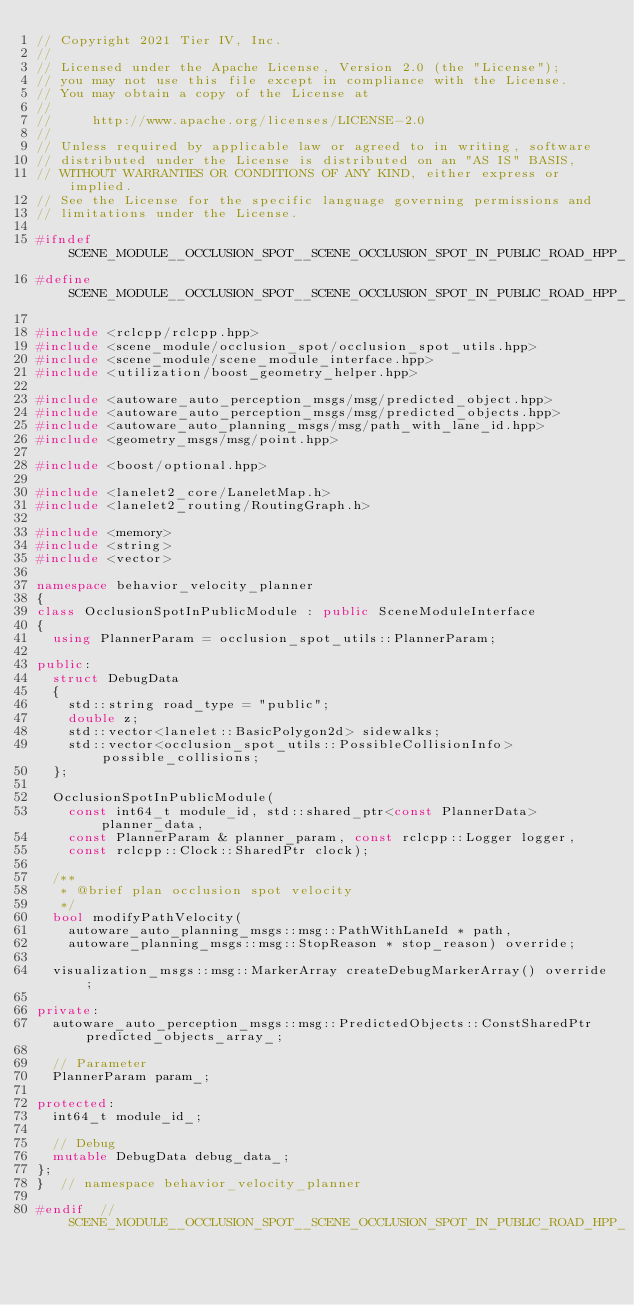Convert code to text. <code><loc_0><loc_0><loc_500><loc_500><_C++_>// Copyright 2021 Tier IV, Inc.
//
// Licensed under the Apache License, Version 2.0 (the "License");
// you may not use this file except in compliance with the License.
// You may obtain a copy of the License at
//
//     http://www.apache.org/licenses/LICENSE-2.0
//
// Unless required by applicable law or agreed to in writing, software
// distributed under the License is distributed on an "AS IS" BASIS,
// WITHOUT WARRANTIES OR CONDITIONS OF ANY KIND, either express or implied.
// See the License for the specific language governing permissions and
// limitations under the License.

#ifndef SCENE_MODULE__OCCLUSION_SPOT__SCENE_OCCLUSION_SPOT_IN_PUBLIC_ROAD_HPP_
#define SCENE_MODULE__OCCLUSION_SPOT__SCENE_OCCLUSION_SPOT_IN_PUBLIC_ROAD_HPP_

#include <rclcpp/rclcpp.hpp>
#include <scene_module/occlusion_spot/occlusion_spot_utils.hpp>
#include <scene_module/scene_module_interface.hpp>
#include <utilization/boost_geometry_helper.hpp>

#include <autoware_auto_perception_msgs/msg/predicted_object.hpp>
#include <autoware_auto_perception_msgs/msg/predicted_objects.hpp>
#include <autoware_auto_planning_msgs/msg/path_with_lane_id.hpp>
#include <geometry_msgs/msg/point.hpp>

#include <boost/optional.hpp>

#include <lanelet2_core/LaneletMap.h>
#include <lanelet2_routing/RoutingGraph.h>

#include <memory>
#include <string>
#include <vector>

namespace behavior_velocity_planner
{
class OcclusionSpotInPublicModule : public SceneModuleInterface
{
  using PlannerParam = occlusion_spot_utils::PlannerParam;

public:
  struct DebugData
  {
    std::string road_type = "public";
    double z;
    std::vector<lanelet::BasicPolygon2d> sidewalks;
    std::vector<occlusion_spot_utils::PossibleCollisionInfo> possible_collisions;
  };

  OcclusionSpotInPublicModule(
    const int64_t module_id, std::shared_ptr<const PlannerData> planner_data,
    const PlannerParam & planner_param, const rclcpp::Logger logger,
    const rclcpp::Clock::SharedPtr clock);

  /**
   * @brief plan occlusion spot velocity
   */
  bool modifyPathVelocity(
    autoware_auto_planning_msgs::msg::PathWithLaneId * path,
    autoware_planning_msgs::msg::StopReason * stop_reason) override;

  visualization_msgs::msg::MarkerArray createDebugMarkerArray() override;

private:
  autoware_auto_perception_msgs::msg::PredictedObjects::ConstSharedPtr predicted_objects_array_;

  // Parameter
  PlannerParam param_;

protected:
  int64_t module_id_;

  // Debug
  mutable DebugData debug_data_;
};
}  // namespace behavior_velocity_planner

#endif  // SCENE_MODULE__OCCLUSION_SPOT__SCENE_OCCLUSION_SPOT_IN_PUBLIC_ROAD_HPP_
</code> 